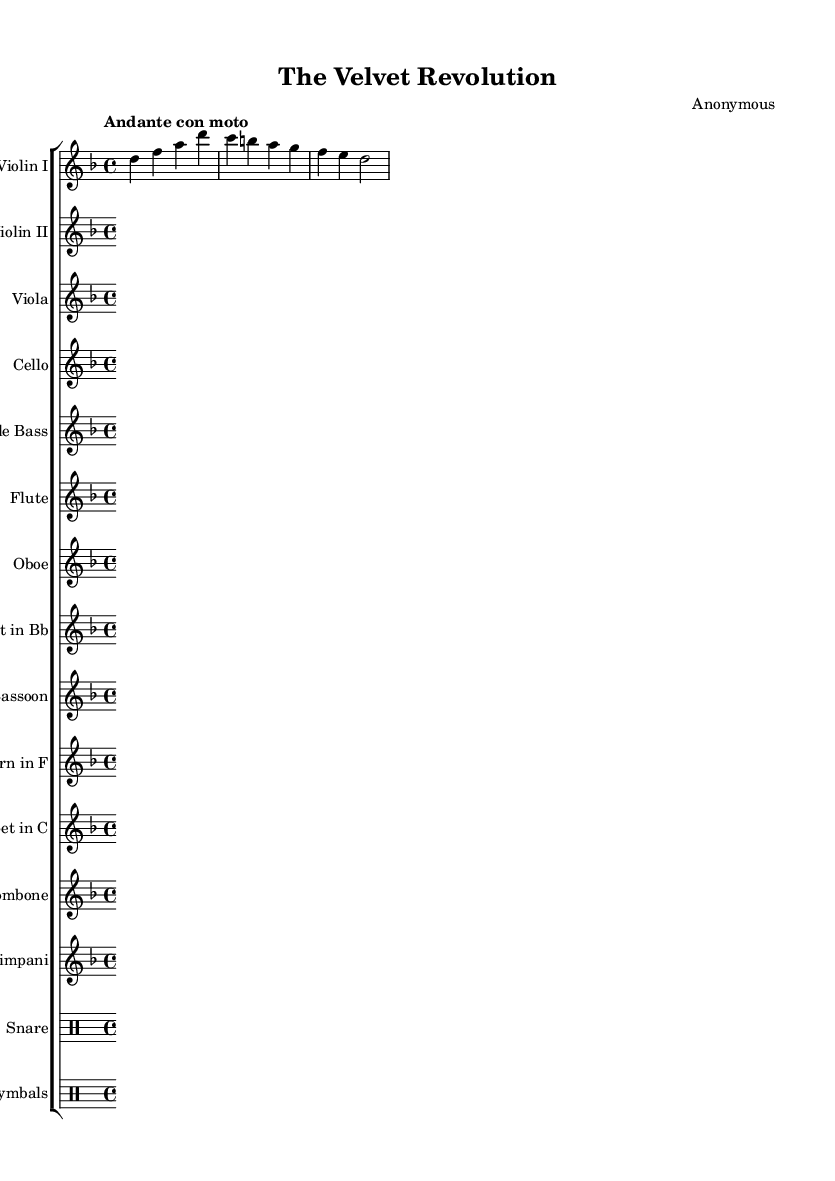What is the key signature of this music? The key signature is specified as D minor, which includes one flat (B flat) in its key signature.
Answer: D minor What is the time signature of this piece? The time signature is indicated as 4/4, which means there are four beats per measure and a quarter note gets one beat.
Answer: 4/4 What is the tempo marking given for the piece? The tempo marking reads "Andante con moto," which translates to a moderately slow tempo with a bit of motion.
Answer: Andante con moto How many staves are used in this orchestral score? The score includes a total of 14 staves for the various instruments, including both string and woodwind sections along with percussion.
Answer: 14 Which instrument is transposed down a whole step? The clarinet in B flat is indicated to be transposed down, which is standard for this instrument, requiring it to play a whole step lower than written.
Answer: Clarinet in B flat What is the overall mood suggested by the combination of key, tempo, and title? The combination of D minor, Andante con moto tempo, and the title "The Velvet Revolution" suggests a reflective, somber mood with an element of hopefulness, often associated with significant historical events.
Answer: Reflective and somber 